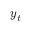Convert formula to latex. <formula><loc_0><loc_0><loc_500><loc_500>\boldsymbol y _ { t }</formula> 